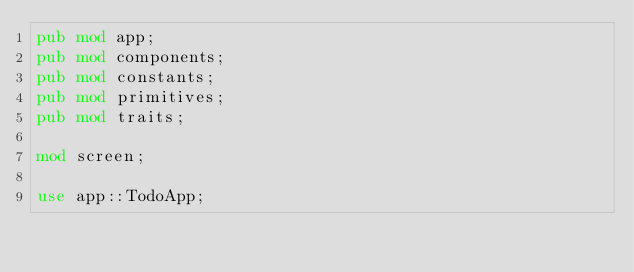Convert code to text. <code><loc_0><loc_0><loc_500><loc_500><_Rust_>pub mod app;
pub mod components;
pub mod constants;
pub mod primitives;
pub mod traits;

mod screen;

use app::TodoApp;</code> 